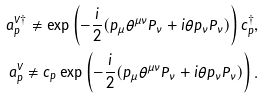Convert formula to latex. <formula><loc_0><loc_0><loc_500><loc_500>a ^ { V \dag } _ { p } \neq \exp \left ( - \frac { i } { 2 } ( p _ { \mu } \theta ^ { \mu \nu } P _ { \nu } + i \theta p _ { \nu } P _ { \nu } ) \right ) c ^ { \dag } _ { p } , \\ a ^ { V } _ { p } \neq c _ { p } \exp \left ( - \frac { i } { 2 } ( p _ { \mu } \theta ^ { \mu \nu } P _ { \nu } + i \theta p _ { \nu } P _ { \nu } ) \right ) .</formula> 